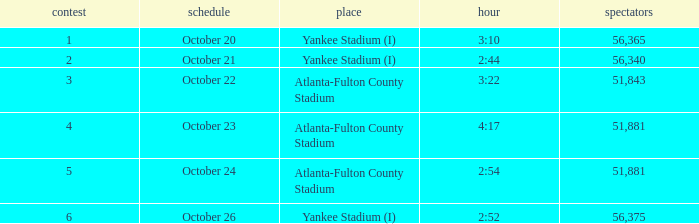What is the highest game number that had a time of 2:44? 2.0. 